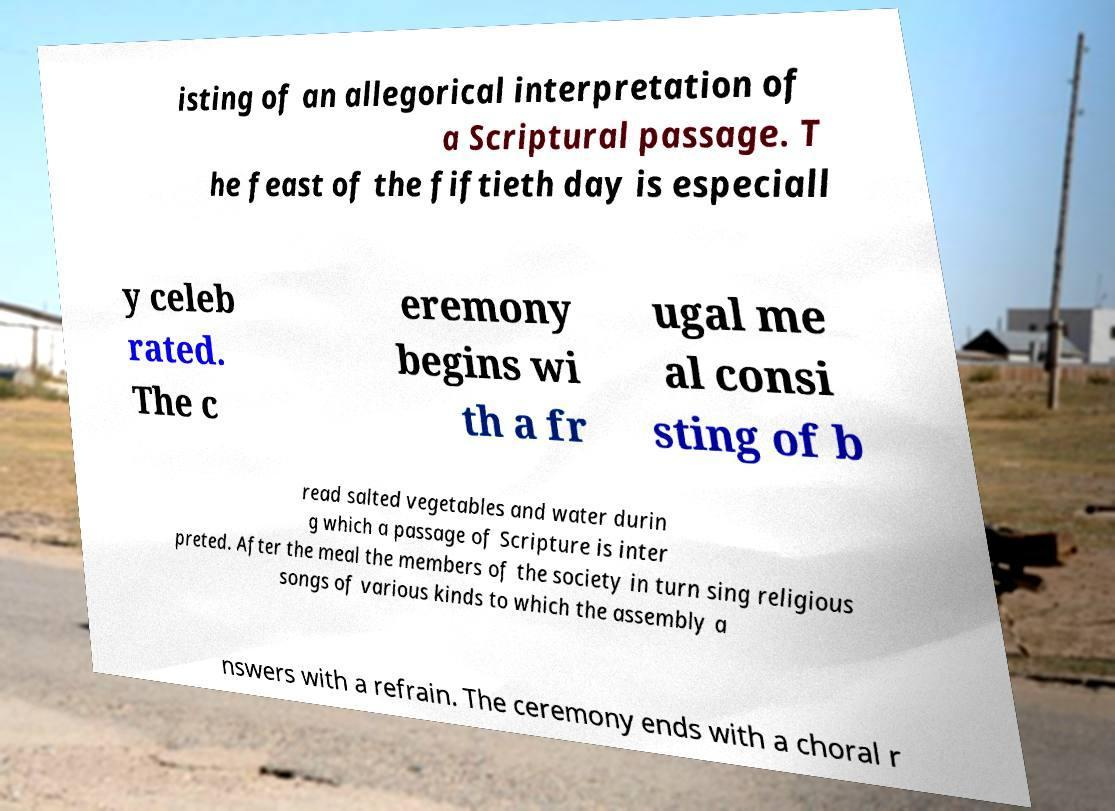Could you assist in decoding the text presented in this image and type it out clearly? isting of an allegorical interpretation of a Scriptural passage. T he feast of the fiftieth day is especiall y celeb rated. The c eremony begins wi th a fr ugal me al consi sting of b read salted vegetables and water durin g which a passage of Scripture is inter preted. After the meal the members of the society in turn sing religious songs of various kinds to which the assembly a nswers with a refrain. The ceremony ends with a choral r 